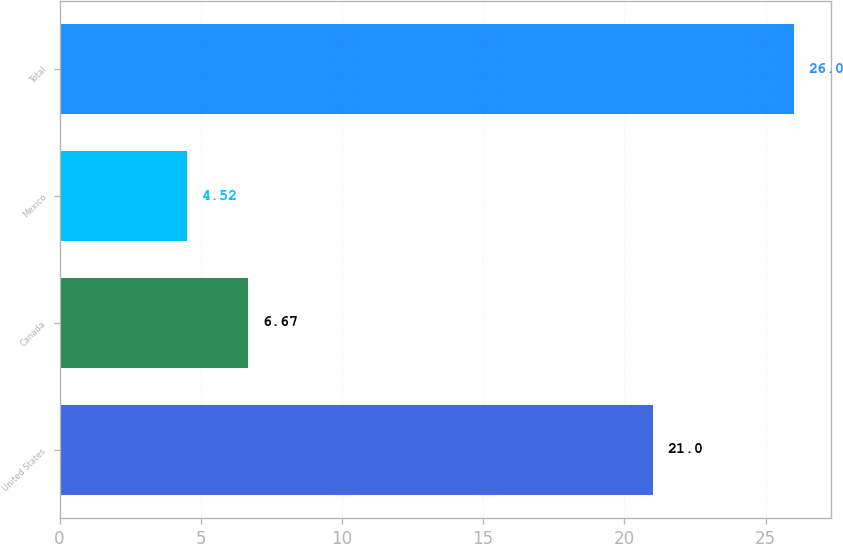Convert chart. <chart><loc_0><loc_0><loc_500><loc_500><bar_chart><fcel>United States<fcel>Canada<fcel>Mexico<fcel>Total<nl><fcel>21<fcel>6.67<fcel>4.52<fcel>26<nl></chart> 